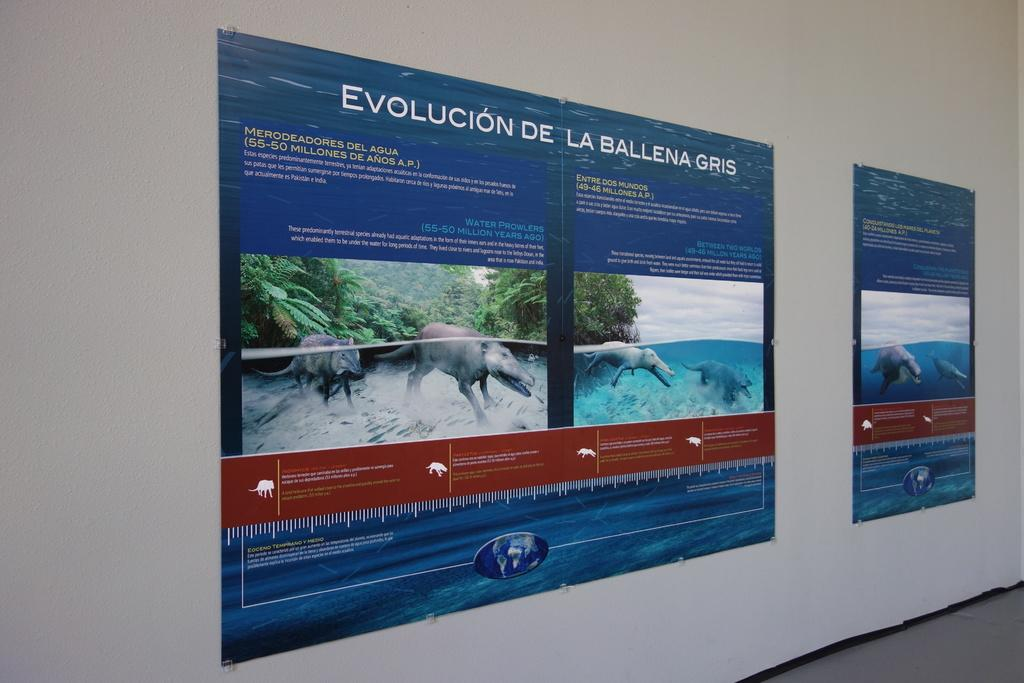What is present on the wall in the image? There are two posters on the wall in the image. Where is the doctor sitting on the throne in the image? There is no doctor or throne present in the image; it only features a wall with two posters. 